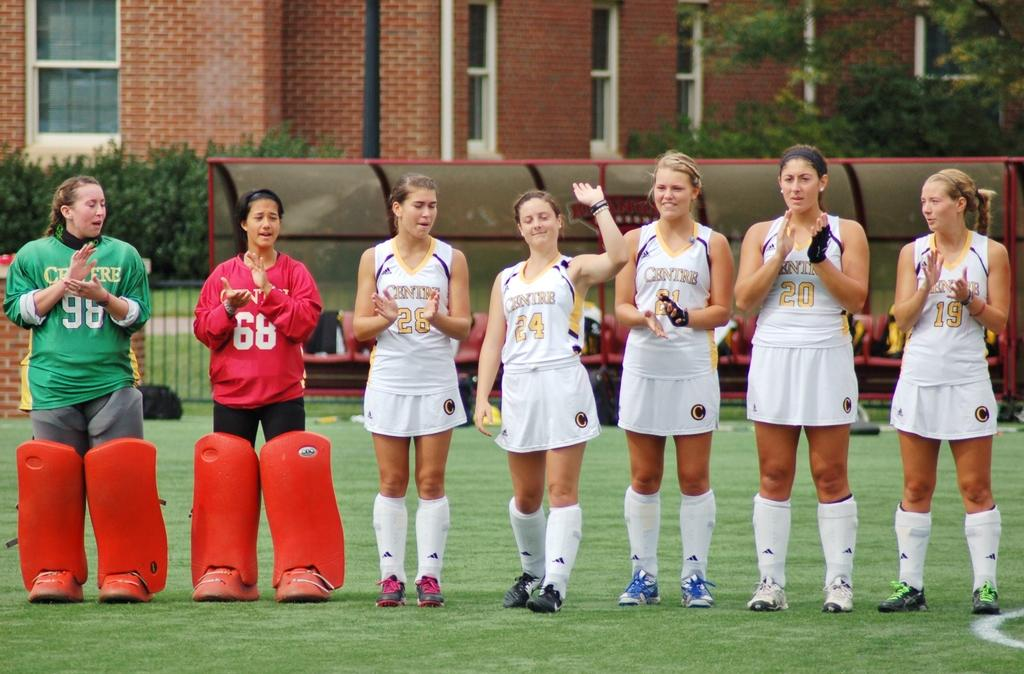How many women are in the image? There are seven women in the image. Where are the women located in the image? The women are standing in a playground. What can be seen in the background of the image? There is a building, trees, and bushes visible in the background of the image. Is there any shelter provided in the image? Yes, there is a roof for shelter in the image. What type of force is being applied by the women in the image? There is no indication in the image that the women are applying any force. Can you see a hammer being used by any of the women in the image? No, there is no hammer present in the image. 